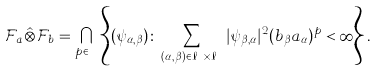<formula> <loc_0><loc_0><loc_500><loc_500>\mathcal { F } _ { a } \hat { \otimes } \mathcal { F } _ { b } = \bigcap _ { p \in \mathbb { N } } \left \{ ( \psi _ { \alpha , \beta } ) \colon \sum _ { ( \alpha , \beta ) \in \ell _ { A } \times \ell _ { B } } | \psi _ { \beta , \alpha } | ^ { 2 } ( b _ { \beta } a _ { \alpha } ) ^ { p } < \infty \right \} .</formula> 